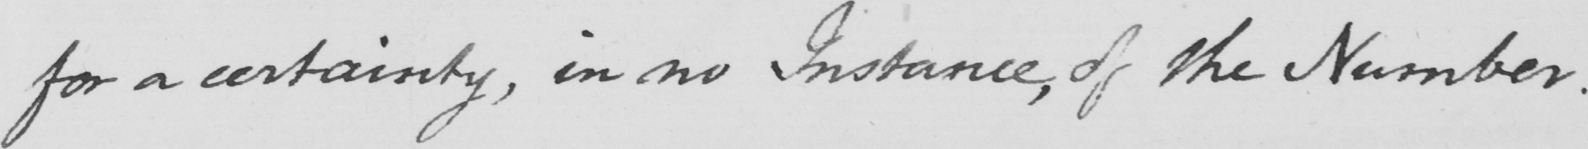Please provide the text content of this handwritten line. for a certainty , in no Instance , of the Number . 